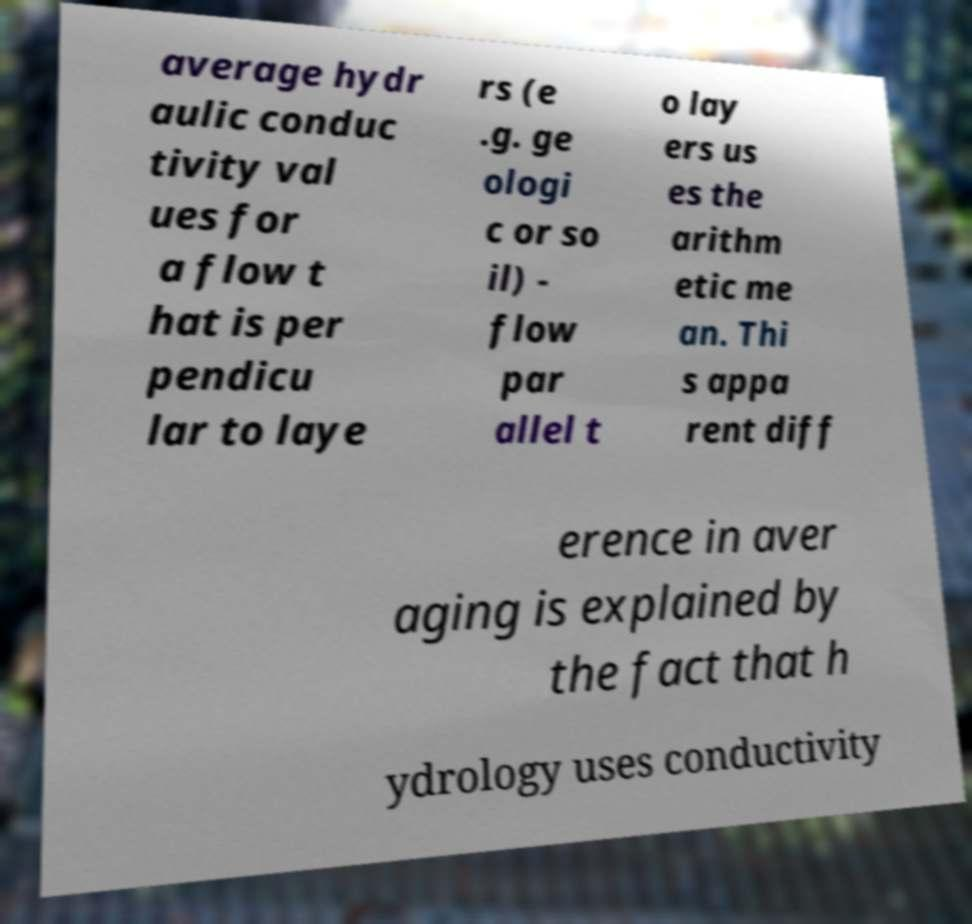Could you assist in decoding the text presented in this image and type it out clearly? average hydr aulic conduc tivity val ues for a flow t hat is per pendicu lar to laye rs (e .g. ge ologi c or so il) - flow par allel t o lay ers us es the arithm etic me an. Thi s appa rent diff erence in aver aging is explained by the fact that h ydrology uses conductivity 